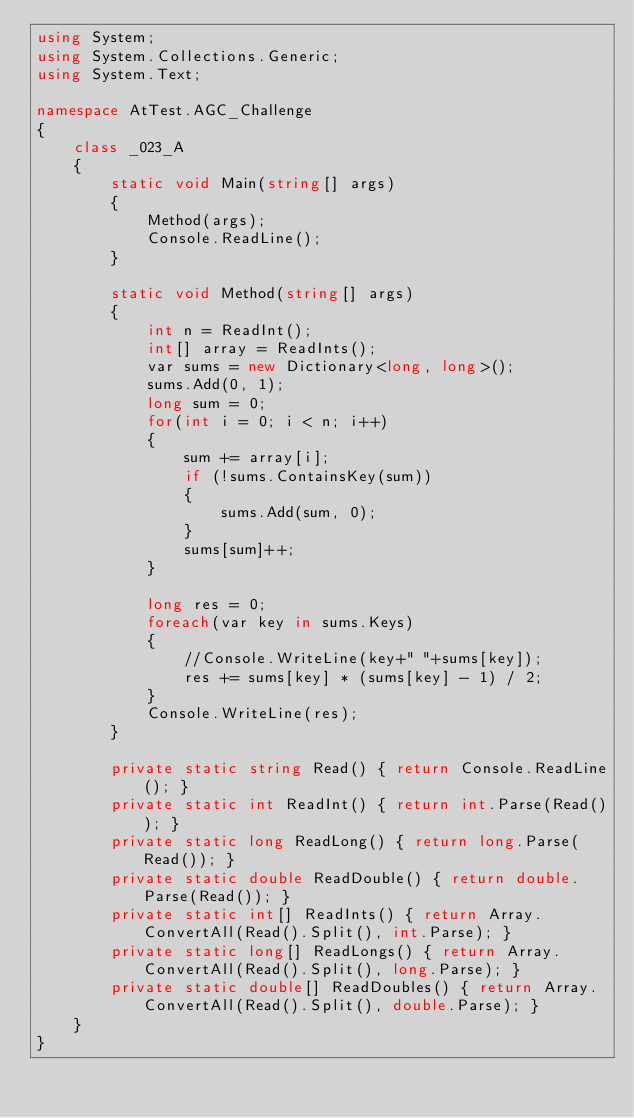Convert code to text. <code><loc_0><loc_0><loc_500><loc_500><_C#_>using System;
using System.Collections.Generic;
using System.Text;

namespace AtTest.AGC_Challenge
{
    class _023_A
    {
        static void Main(string[] args)
        {
            Method(args);
            Console.ReadLine();
        }

        static void Method(string[] args)
        {
            int n = ReadInt();
            int[] array = ReadInts();
            var sums = new Dictionary<long, long>();
            sums.Add(0, 1);
            long sum = 0;
            for(int i = 0; i < n; i++)
            {
                sum += array[i];
                if (!sums.ContainsKey(sum))
                {
                    sums.Add(sum, 0);
                }
                sums[sum]++;
            }

            long res = 0;
            foreach(var key in sums.Keys)
            {
                //Console.WriteLine(key+" "+sums[key]);
                res += sums[key] * (sums[key] - 1) / 2;
            }
            Console.WriteLine(res);
        }

        private static string Read() { return Console.ReadLine(); }
        private static int ReadInt() { return int.Parse(Read()); }
        private static long ReadLong() { return long.Parse(Read()); }
        private static double ReadDouble() { return double.Parse(Read()); }
        private static int[] ReadInts() { return Array.ConvertAll(Read().Split(), int.Parse); }
        private static long[] ReadLongs() { return Array.ConvertAll(Read().Split(), long.Parse); }
        private static double[] ReadDoubles() { return Array.ConvertAll(Read().Split(), double.Parse); }
    }
}
</code> 